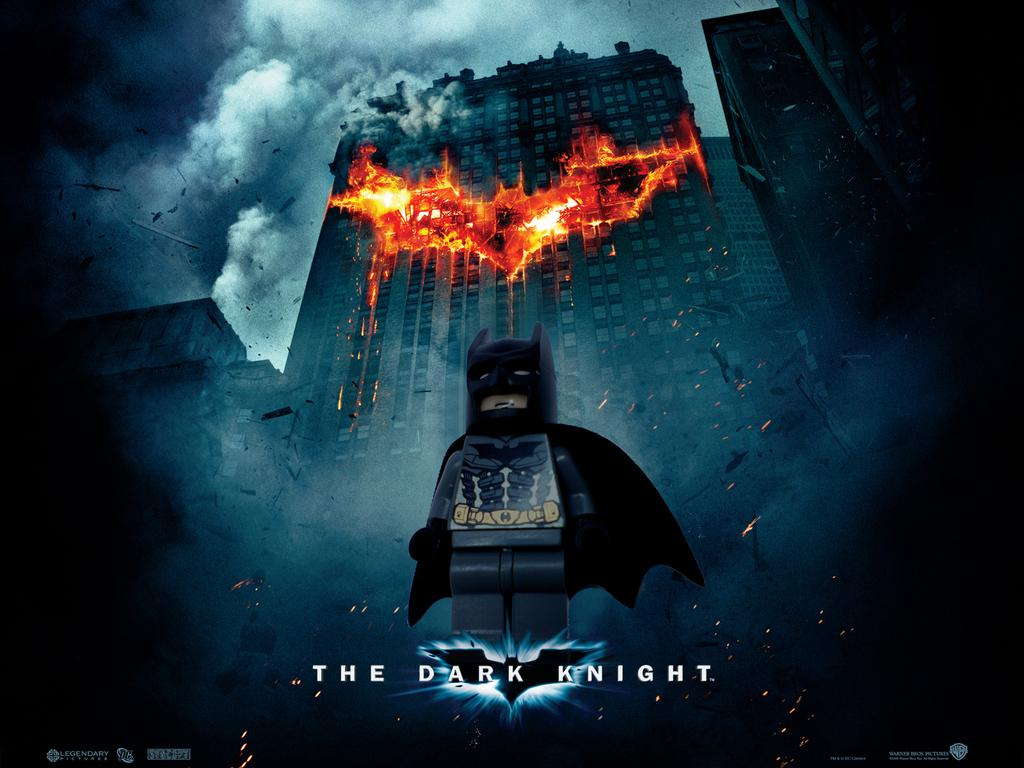Provide a one-sentence caption for the provided image. A  poster from the movie The Dark Knight in front of the burning building. 